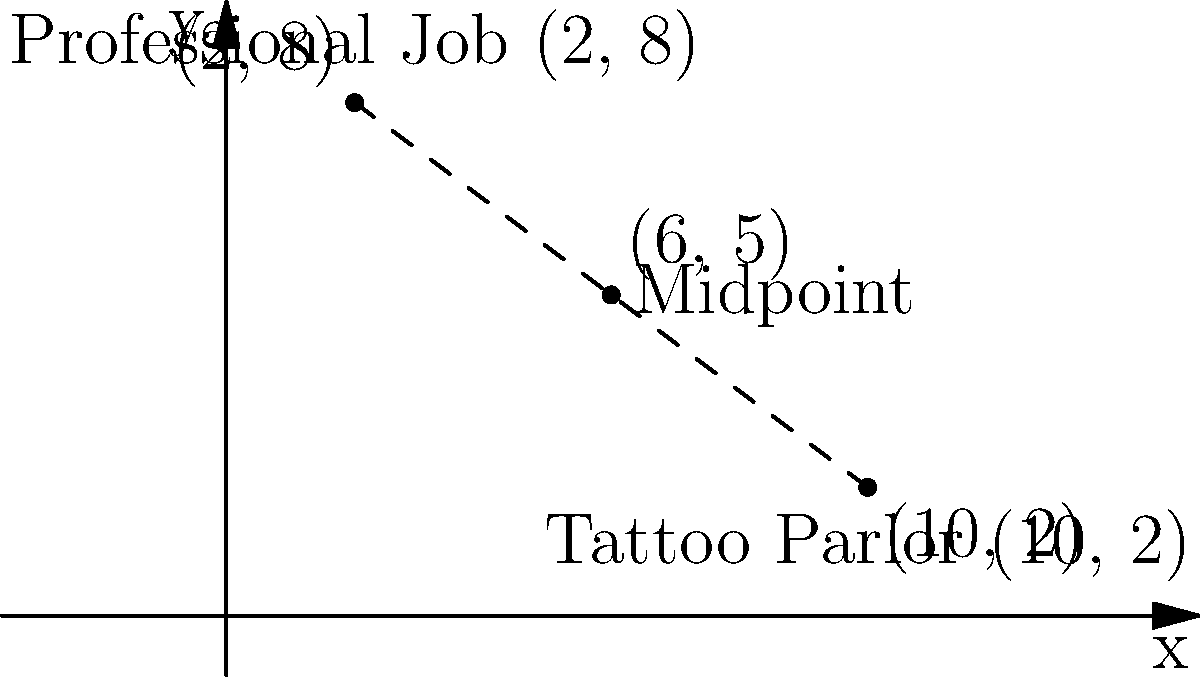Your child is considering two career options: a professional job at coordinates (2, 8) and working at a tattoo parlor at coordinates (10, 2). To find a compromise, you suggest meeting at the midpoint between these two locations. What are the coordinates of this midpoint? To find the midpoint between two points, we use the midpoint formula:

$$ \text{Midpoint} = \left(\frac{x_1 + x_2}{2}, \frac{y_1 + y_2}{2}\right) $$

Where $(x_1, y_1)$ is the first point and $(x_2, y_2)$ is the second point.

1. Identify the coordinates:
   - Professional job: $(x_1, y_1) = (2, 8)$
   - Tattoo parlor: $(x_2, y_2) = (10, 2)$

2. Calculate the x-coordinate of the midpoint:
   $$ x = \frac{x_1 + x_2}{2} = \frac{2 + 10}{2} = \frac{12}{2} = 6 $$

3. Calculate the y-coordinate of the midpoint:
   $$ y = \frac{y_1 + y_2}{2} = \frac{8 + 2}{2} = \frac{10}{2} = 5 $$

4. Combine the results to get the midpoint coordinates: (6, 5)
Answer: (6, 5) 